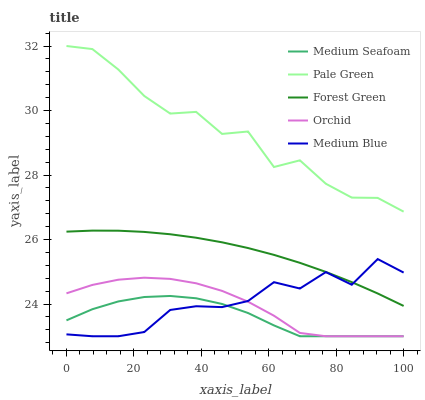Does Medium Seafoam have the minimum area under the curve?
Answer yes or no. Yes. Does Pale Green have the maximum area under the curve?
Answer yes or no. Yes. Does Medium Blue have the minimum area under the curve?
Answer yes or no. No. Does Medium Blue have the maximum area under the curve?
Answer yes or no. No. Is Forest Green the smoothest?
Answer yes or no. Yes. Is Pale Green the roughest?
Answer yes or no. Yes. Is Medium Blue the smoothest?
Answer yes or no. No. Is Medium Blue the roughest?
Answer yes or no. No. Does Medium Blue have the lowest value?
Answer yes or no. Yes. Does Pale Green have the lowest value?
Answer yes or no. No. Does Pale Green have the highest value?
Answer yes or no. Yes. Does Medium Blue have the highest value?
Answer yes or no. No. Is Orchid less than Pale Green?
Answer yes or no. Yes. Is Pale Green greater than Orchid?
Answer yes or no. Yes. Does Orchid intersect Medium Seafoam?
Answer yes or no. Yes. Is Orchid less than Medium Seafoam?
Answer yes or no. No. Is Orchid greater than Medium Seafoam?
Answer yes or no. No. Does Orchid intersect Pale Green?
Answer yes or no. No. 